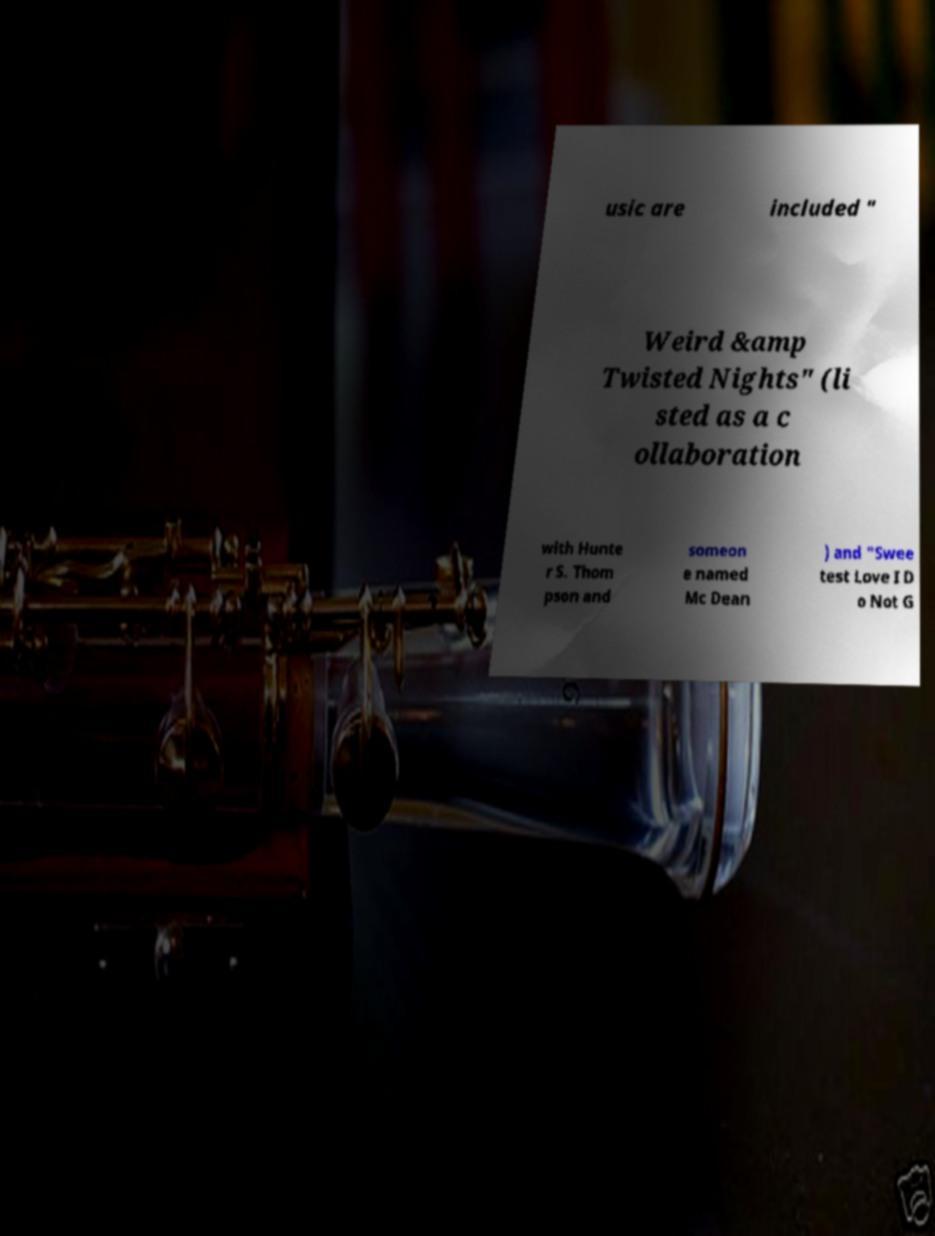Could you assist in decoding the text presented in this image and type it out clearly? usic are included " Weird &amp Twisted Nights" (li sted as a c ollaboration with Hunte r S. Thom pson and someon e named Mc Dean ) and "Swee test Love I D o Not G 